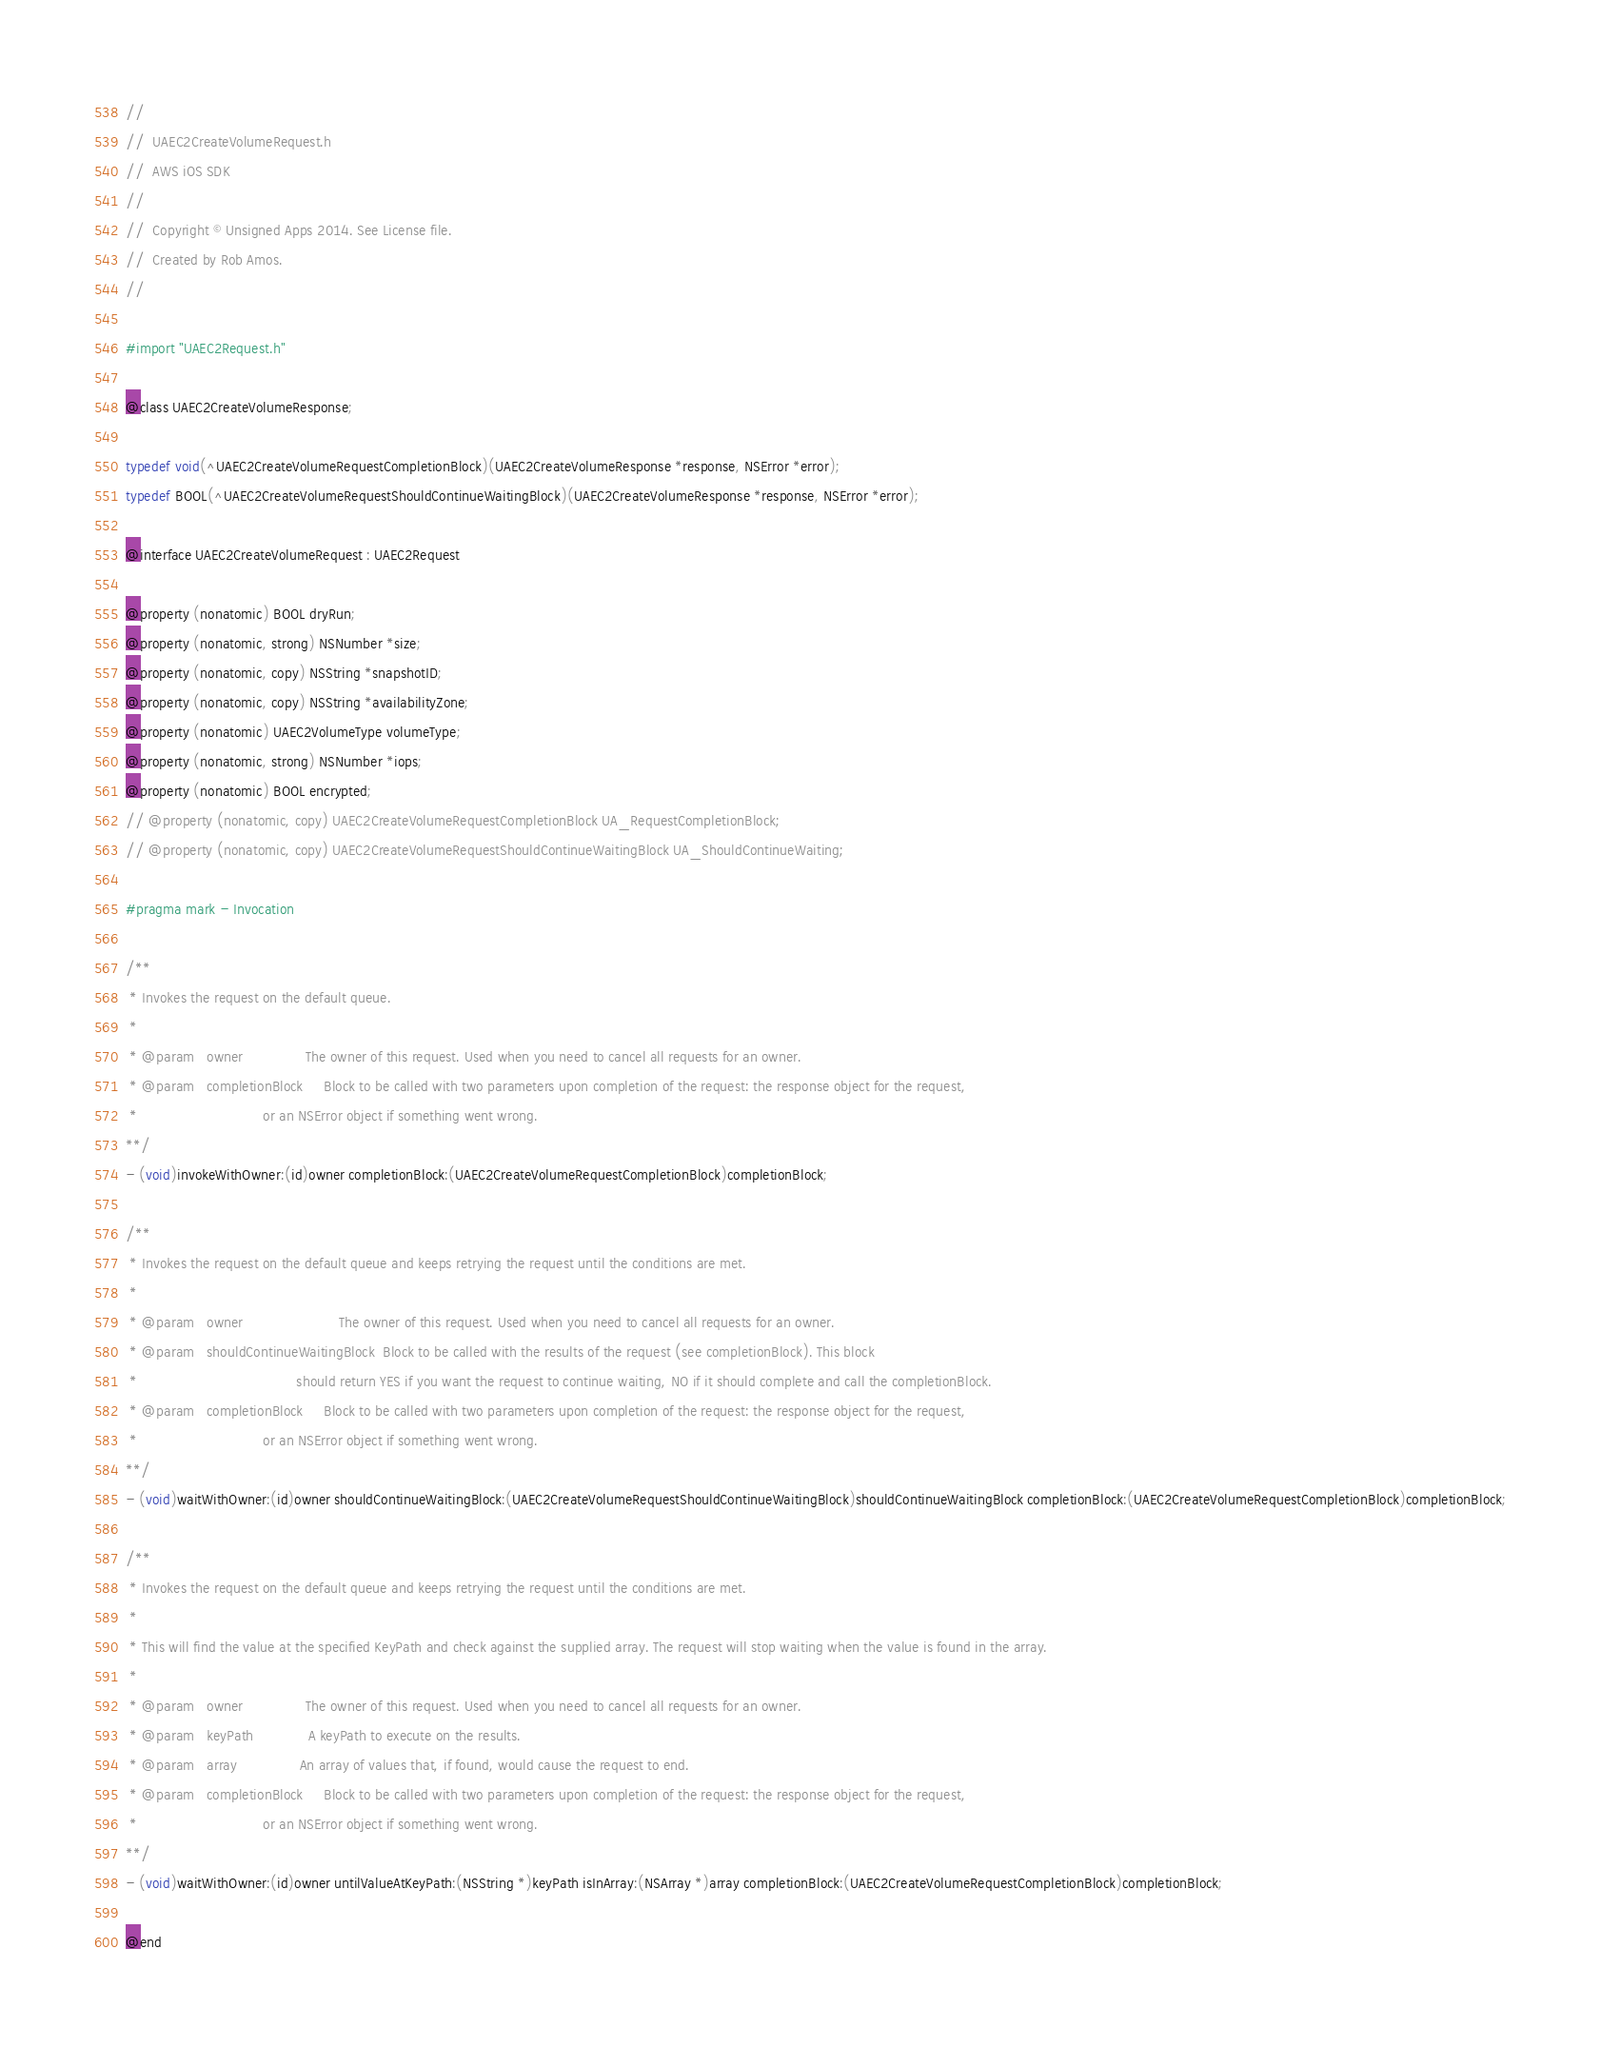Convert code to text. <code><loc_0><loc_0><loc_500><loc_500><_C_>//
//  UAEC2CreateVolumeRequest.h
//  AWS iOS SDK
//
//  Copyright © Unsigned Apps 2014. See License file.
//  Created by Rob Amos.
//

#import "UAEC2Request.h"

@class UAEC2CreateVolumeResponse;

typedef void(^UAEC2CreateVolumeRequestCompletionBlock)(UAEC2CreateVolumeResponse *response, NSError *error);
typedef BOOL(^UAEC2CreateVolumeRequestShouldContinueWaitingBlock)(UAEC2CreateVolumeResponse *response, NSError *error);

@interface UAEC2CreateVolumeRequest : UAEC2Request

@property (nonatomic) BOOL dryRun;
@property (nonatomic, strong) NSNumber *size;
@property (nonatomic, copy) NSString *snapshotID;
@property (nonatomic, copy) NSString *availabilityZone;
@property (nonatomic) UAEC2VolumeType volumeType;
@property (nonatomic, strong) NSNumber *iops;
@property (nonatomic) BOOL encrypted;
// @property (nonatomic, copy) UAEC2CreateVolumeRequestCompletionBlock UA_RequestCompletionBlock;
// @property (nonatomic, copy) UAEC2CreateVolumeRequestShouldContinueWaitingBlock UA_ShouldContinueWaiting;

#pragma mark - Invocation

/**
 * Invokes the request on the default queue.
 *
 * @param	owner				The owner of this request. Used when you need to cancel all requests for an owner.
 * @param	completionBlock		Block to be called with two parameters upon completion of the request: the response object for the request,
 *								or an NSError object if something went wrong.
**/
- (void)invokeWithOwner:(id)owner completionBlock:(UAEC2CreateVolumeRequestCompletionBlock)completionBlock;

/**
 * Invokes the request on the default queue and keeps retrying the request until the conditions are met.
 *
 * @param	owner						The owner of this request. Used when you need to cancel all requests for an owner.
 * @param	shouldContinueWaitingBlock 	Block to be called with the results of the request (see completionBlock). This block
 *										should return YES if you want the request to continue waiting, NO if it should complete and call the completionBlock.
 * @param	completionBlock		Block to be called with two parameters upon completion of the request: the response object for the request,
 *								or an NSError object if something went wrong.
**/
- (void)waitWithOwner:(id)owner shouldContinueWaitingBlock:(UAEC2CreateVolumeRequestShouldContinueWaitingBlock)shouldContinueWaitingBlock completionBlock:(UAEC2CreateVolumeRequestCompletionBlock)completionBlock;

/**
 * Invokes the request on the default queue and keeps retrying the request until the conditions are met.
 *
 * This will find the value at the specified KeyPath and check against the supplied array. The request will stop waiting when the value is found in the array.
 *
 * @param	owner				The owner of this request. Used when you need to cancel all requests for an owner.
 * @param	keyPath				A keyPath to execute on the results.
 * @param	array 				An array of values that, if found, would cause the request to end.
 * @param	completionBlock		Block to be called with two parameters upon completion of the request: the response object for the request,
 *								or an NSError object if something went wrong.
**/
- (void)waitWithOwner:(id)owner untilValueAtKeyPath:(NSString *)keyPath isInArray:(NSArray *)array completionBlock:(UAEC2CreateVolumeRequestCompletionBlock)completionBlock;

@end
</code> 